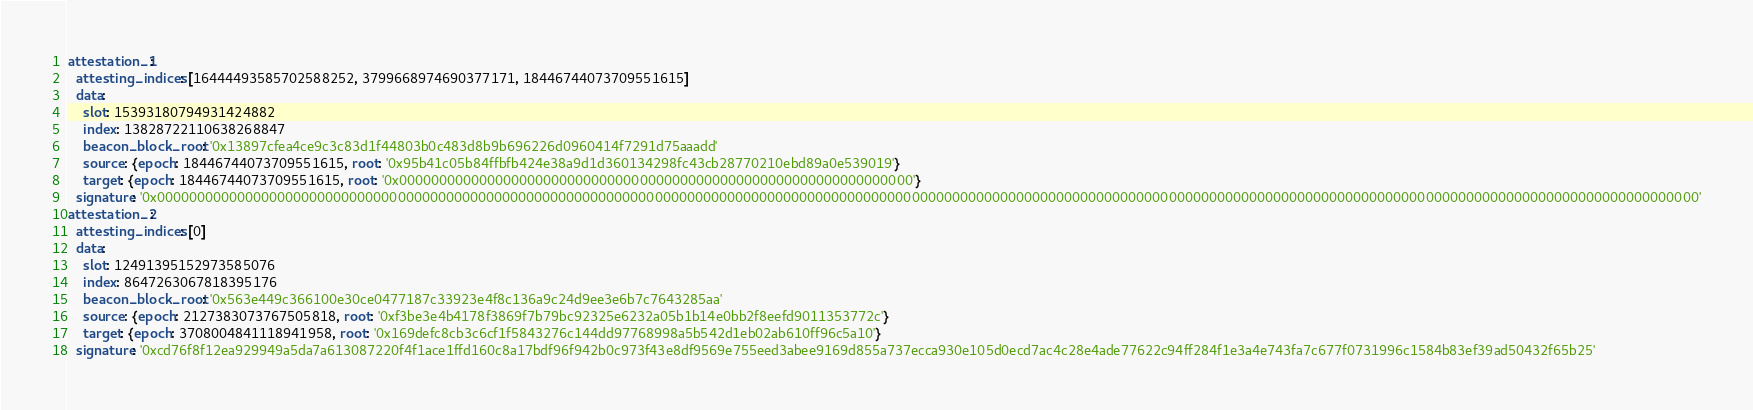<code> <loc_0><loc_0><loc_500><loc_500><_YAML_>attestation_1:
  attesting_indices: [16444493585702588252, 3799668974690377171, 18446744073709551615]
  data:
    slot: 15393180794931424882
    index: 13828722110638268847
    beacon_block_root: '0x13897cfea4ce9c3c83d1f44803b0c483d8b9b696226d0960414f7291d75aaadd'
    source: {epoch: 18446744073709551615, root: '0x95b41c05b84ffbfb424e38a9d1d360134298fc43cb28770210ebd89a0e539019'}
    target: {epoch: 18446744073709551615, root: '0x0000000000000000000000000000000000000000000000000000000000000000'}
  signature: '0x000000000000000000000000000000000000000000000000000000000000000000000000000000000000000000000000000000000000000000000000000000000000000000000000000000000000000000000000000000000000000000000000'
attestation_2:
  attesting_indices: [0]
  data:
    slot: 12491395152973585076
    index: 8647263067818395176
    beacon_block_root: '0x563e449c366100e30ce0477187c33923e4f8c136a9c24d9ee3e6b7c7643285aa'
    source: {epoch: 2127383073767505818, root: '0xf3be3e4b4178f3869f7b79bc92325e6232a05b1b14e0bb2f8eefd9011353772c'}
    target: {epoch: 3708004841118941958, root: '0x169defc8cb3c6cf1f5843276c144dd97768998a5b542d1eb02ab610ff96c5a10'}
  signature: '0xcd76f8f12ea929949a5da7a613087220f4f1ace1ffd160c8a17bdf96f942b0c973f43e8df9569e755eed3abee9169d855a737ecca930e105d0ecd7ac4c28e4ade77622c94ff284f1e3a4e743fa7c677f0731996c1584b83ef39ad50432f65b25'
</code> 